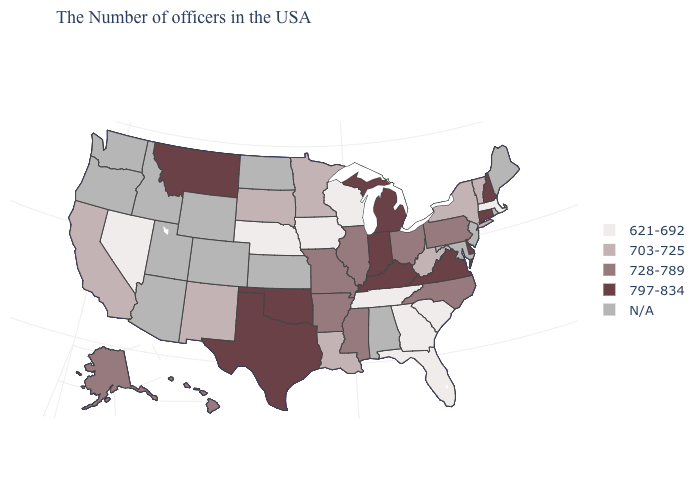What is the value of Kansas?
Write a very short answer. N/A. Is the legend a continuous bar?
Keep it brief. No. What is the value of Oregon?
Be succinct. N/A. Name the states that have a value in the range 797-834?
Quick response, please. New Hampshire, Connecticut, Delaware, Virginia, Michigan, Kentucky, Indiana, Oklahoma, Texas, Montana. What is the value of Oregon?
Quick response, please. N/A. What is the value of Virginia?
Write a very short answer. 797-834. What is the highest value in the USA?
Keep it brief. 797-834. Which states have the lowest value in the Northeast?
Concise answer only. Massachusetts. Among the states that border Connecticut , which have the lowest value?
Be succinct. Massachusetts. What is the value of Nebraska?
Quick response, please. 621-692. Name the states that have a value in the range 728-789?
Answer briefly. Pennsylvania, North Carolina, Ohio, Illinois, Mississippi, Missouri, Arkansas, Alaska, Hawaii. Among the states that border Virginia , which have the highest value?
Write a very short answer. Kentucky. What is the lowest value in the USA?
Be succinct. 621-692. What is the value of Colorado?
Give a very brief answer. N/A. What is the value of Michigan?
Quick response, please. 797-834. 